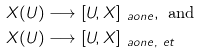Convert formula to latex. <formula><loc_0><loc_0><loc_500><loc_500>X ( U ) & \longrightarrow [ U , X ] _ { \ a o n e } , \text { and } \\ X ( U ) & \longrightarrow [ U , X ] _ { \ a o n e , \ e t }</formula> 